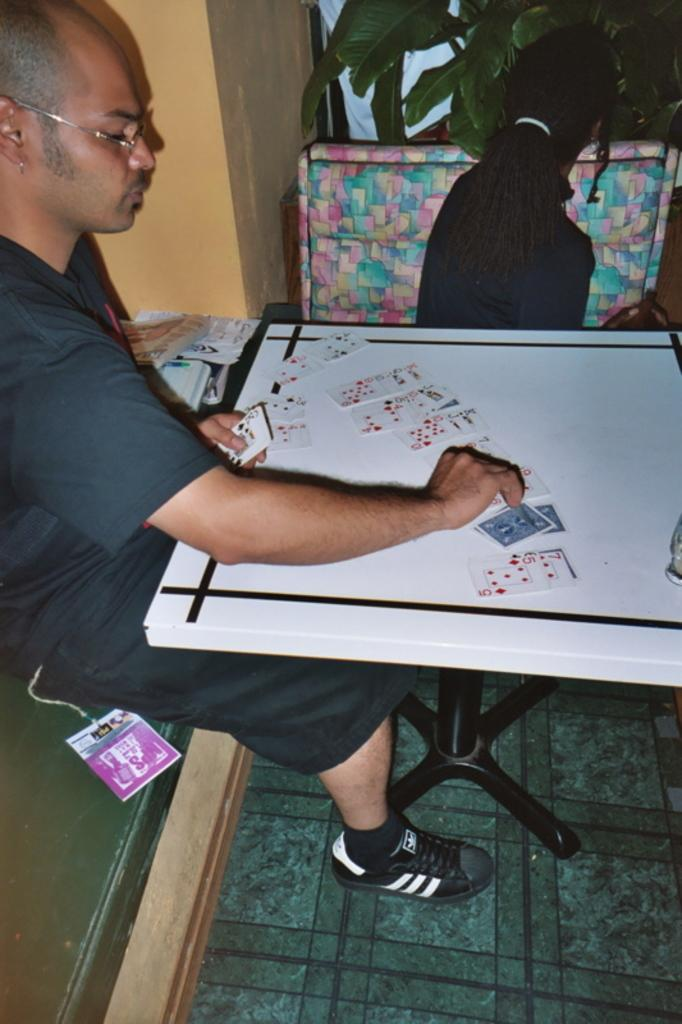What is the man in the image doing? The man is sitting and placing cards on a table in the image. Can you describe the other person in the image? There is a person sitting in the image, but their actions are not specified. What type of vegetation is present in the image? There is a green plant in the image. What can be seen in the background of the image? There is a wall visible in the image. What type of drink is being shared between the two people in the image? There are no drinks present in the image, and only one person is clearly visible. 